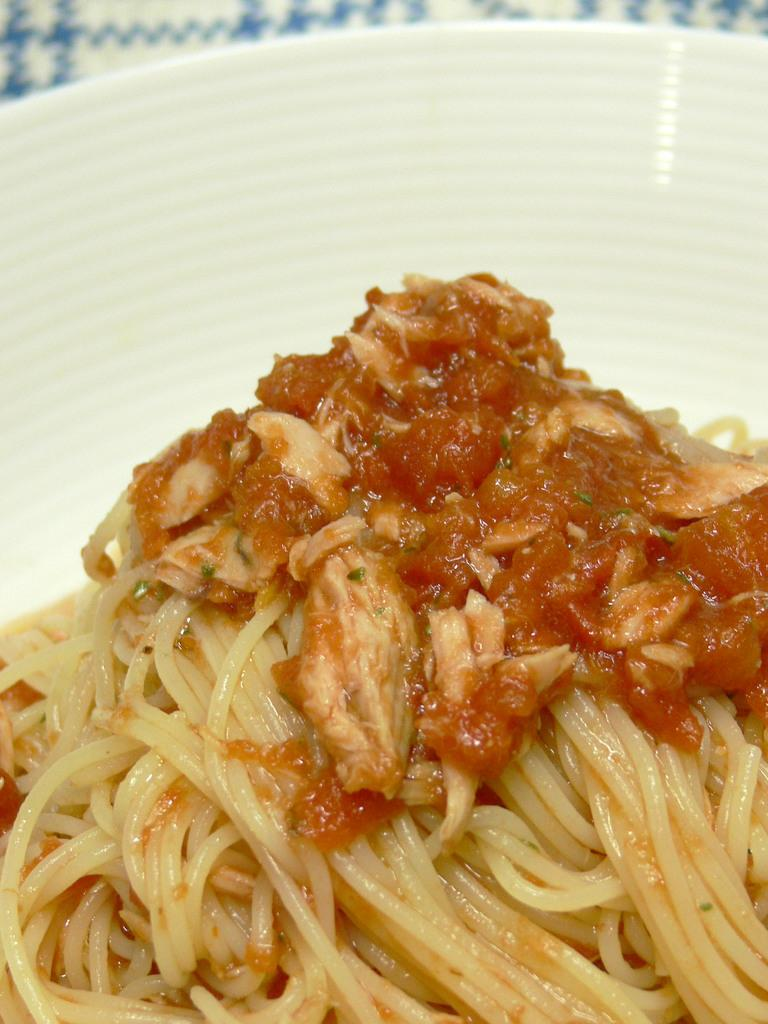What is in the bowl that is visible in the image? There is a bowl in the image, and it contains noodles. Are there any other food items in the bowl besides noodles? Yes, there are other food stuff in the bowl. How many stars can be seen in the mouth of the person eating the noodles in the image? There is no person eating noodles or any stars visible in the image. 